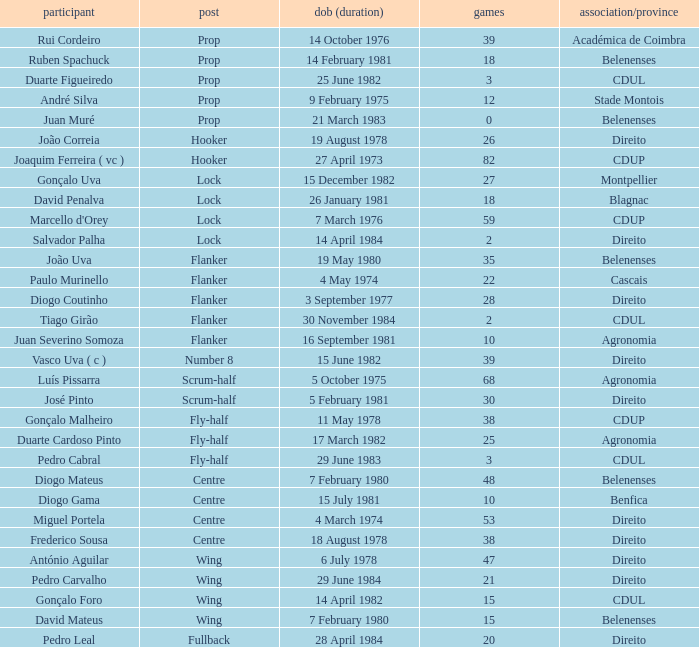How many caps have a Date of Birth (Age) of 15 july 1981? 1.0. 